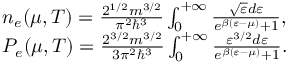Convert formula to latex. <formula><loc_0><loc_0><loc_500><loc_500>\begin{array} { r l } & { { n _ { e } ( \mu , T ) } = \frac { { { 2 ^ { 1 / 2 } } m { ^ { 3 / 2 } } } } { { { \pi ^ { 2 } } { \hbar { ^ } { 3 } } } } \int _ { 0 } ^ { + \infty } { \frac { { \sqrt { \varepsilon } d { \varepsilon } } } { { { e ^ { \beta ( { \varepsilon } - \mu ) } } + 1 } } } , } \\ & { { P _ { e } ( \mu , T ) } = \frac { { { 2 ^ { 3 / 2 } } m { ^ { 3 / 2 } } } } { { 3 { \pi ^ { 2 } } { \hbar { ^ } { 3 } } } } \int _ { 0 } ^ { + \infty } { \frac { { { { \varepsilon } ^ { 3 / 2 } } d { \varepsilon } } } { { { e ^ { \beta ( { \varepsilon } - { \mu } ) } } + 1 } } . } } \end{array}</formula> 